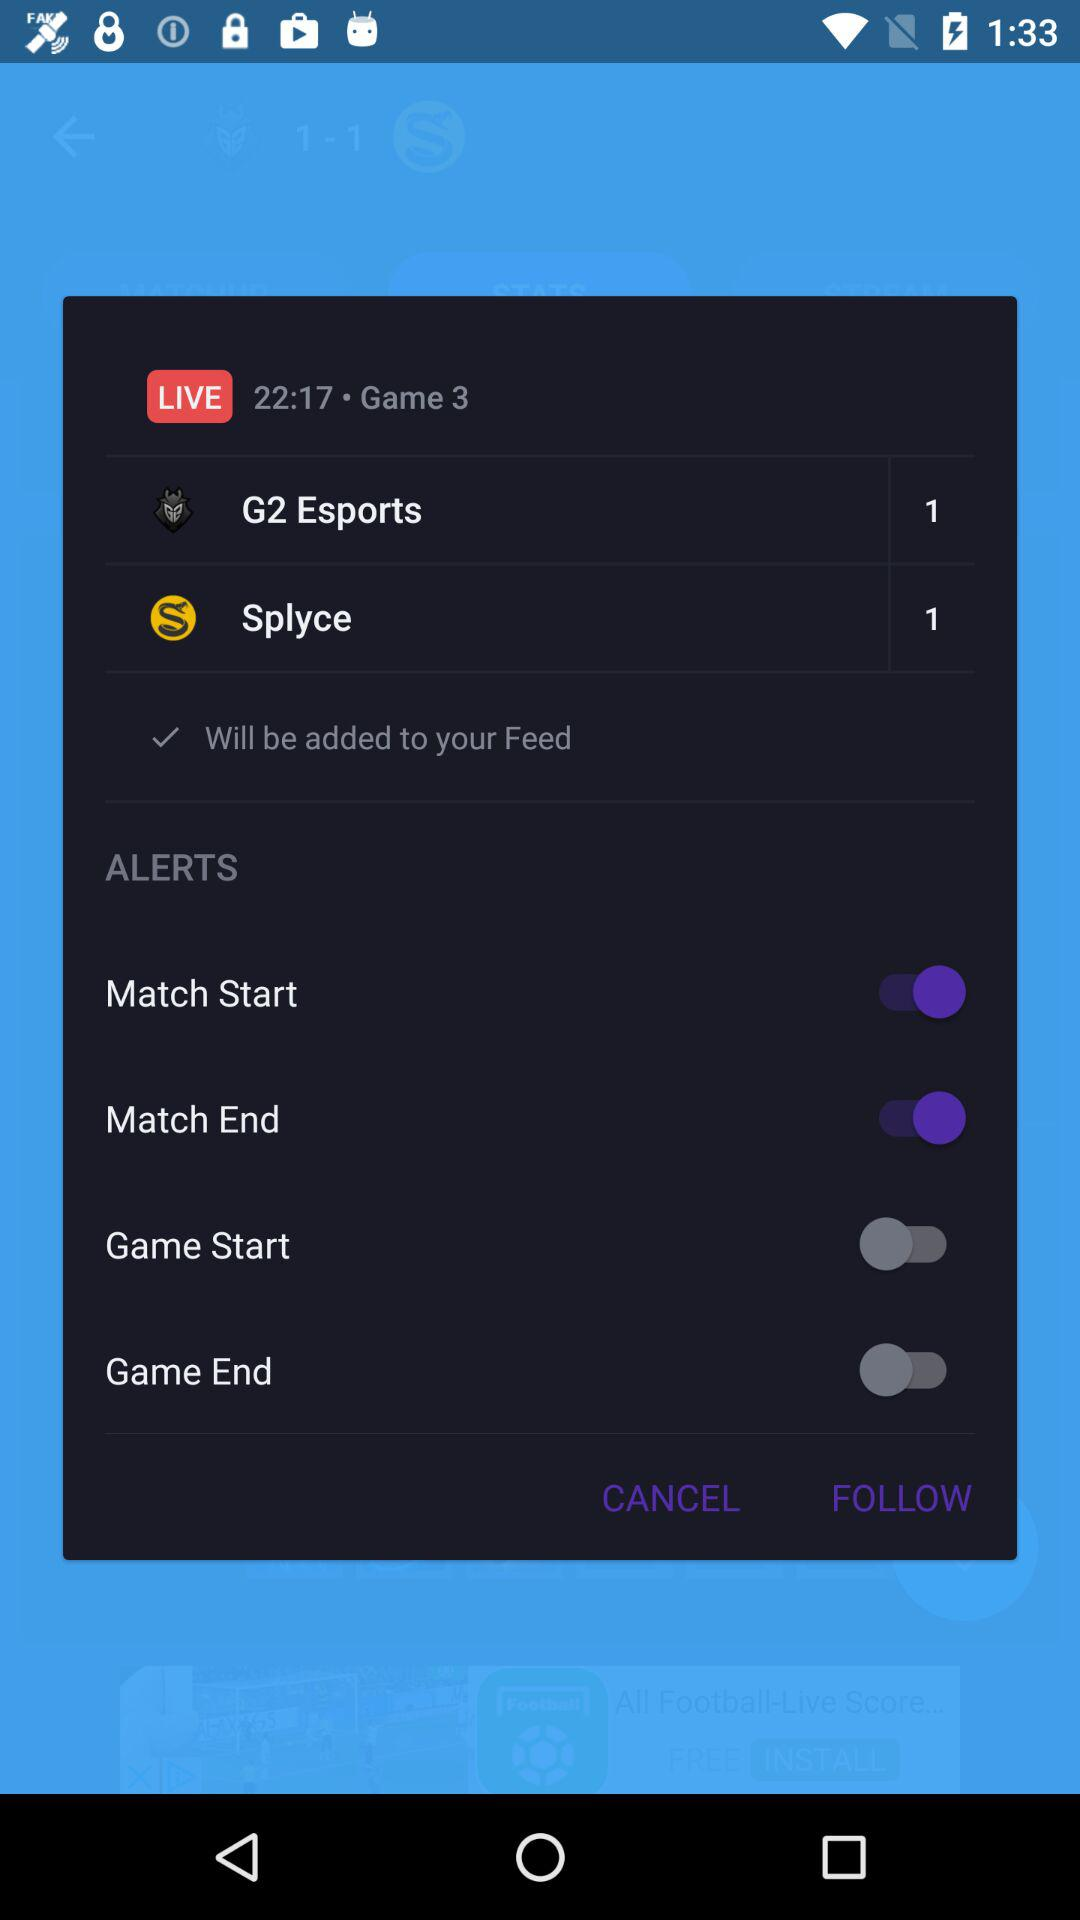What is the status of Match Start? The status is on. 